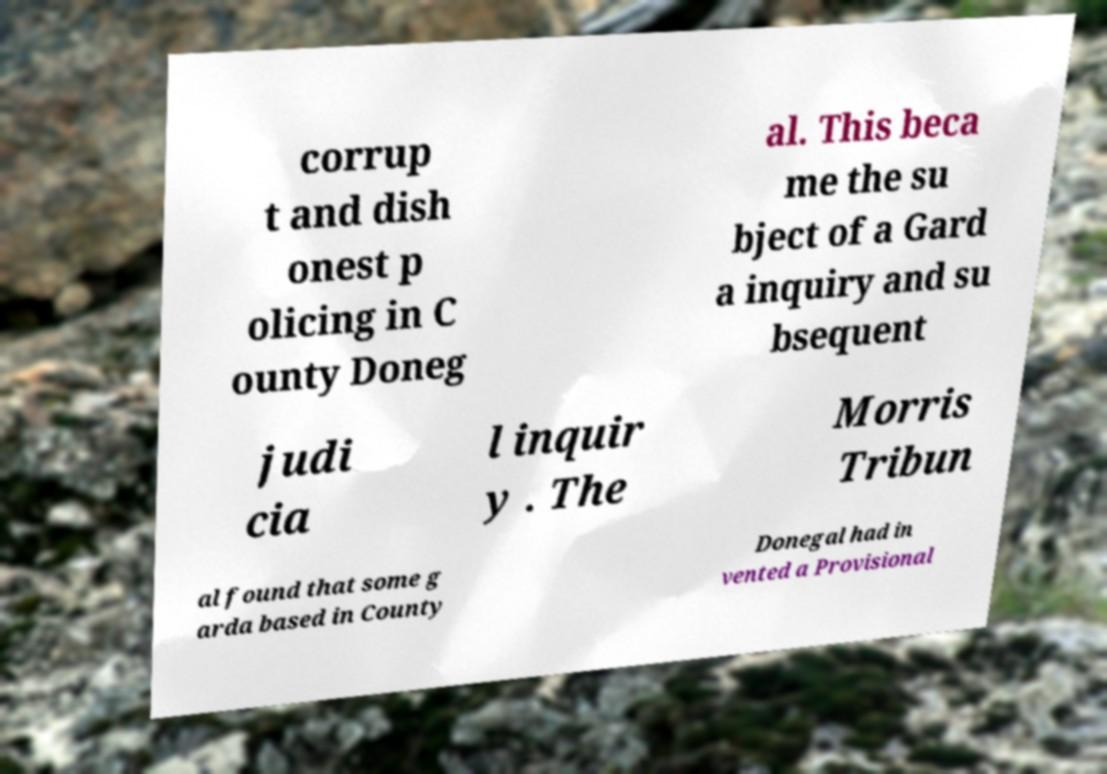Can you accurately transcribe the text from the provided image for me? corrup t and dish onest p olicing in C ounty Doneg al. This beca me the su bject of a Gard a inquiry and su bsequent judi cia l inquir y . The Morris Tribun al found that some g arda based in County Donegal had in vented a Provisional 